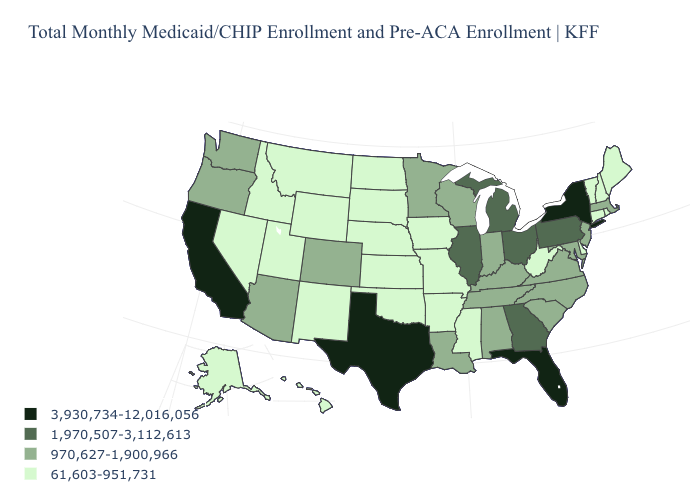What is the value of Rhode Island?
Be succinct. 61,603-951,731. What is the value of North Dakota?
Be succinct. 61,603-951,731. What is the lowest value in the USA?
Short answer required. 61,603-951,731. Name the states that have a value in the range 61,603-951,731?
Give a very brief answer. Alaska, Arkansas, Connecticut, Delaware, Hawaii, Idaho, Iowa, Kansas, Maine, Mississippi, Missouri, Montana, Nebraska, Nevada, New Hampshire, New Mexico, North Dakota, Oklahoma, Rhode Island, South Dakota, Utah, Vermont, West Virginia, Wyoming. Name the states that have a value in the range 1,970,507-3,112,613?
Give a very brief answer. Georgia, Illinois, Michigan, Ohio, Pennsylvania. Among the states that border North Carolina , does Georgia have the lowest value?
Short answer required. No. Does Texas have the highest value in the USA?
Keep it brief. Yes. Name the states that have a value in the range 1,970,507-3,112,613?
Keep it brief. Georgia, Illinois, Michigan, Ohio, Pennsylvania. What is the highest value in states that border North Carolina?
Quick response, please. 1,970,507-3,112,613. Name the states that have a value in the range 61,603-951,731?
Give a very brief answer. Alaska, Arkansas, Connecticut, Delaware, Hawaii, Idaho, Iowa, Kansas, Maine, Mississippi, Missouri, Montana, Nebraska, Nevada, New Hampshire, New Mexico, North Dakota, Oklahoma, Rhode Island, South Dakota, Utah, Vermont, West Virginia, Wyoming. Is the legend a continuous bar?
Short answer required. No. What is the value of Wyoming?
Quick response, please. 61,603-951,731. Name the states that have a value in the range 3,930,734-12,016,056?
Quick response, please. California, Florida, New York, Texas. Name the states that have a value in the range 3,930,734-12,016,056?
Be succinct. California, Florida, New York, Texas. Does Pennsylvania have the highest value in the Northeast?
Quick response, please. No. 